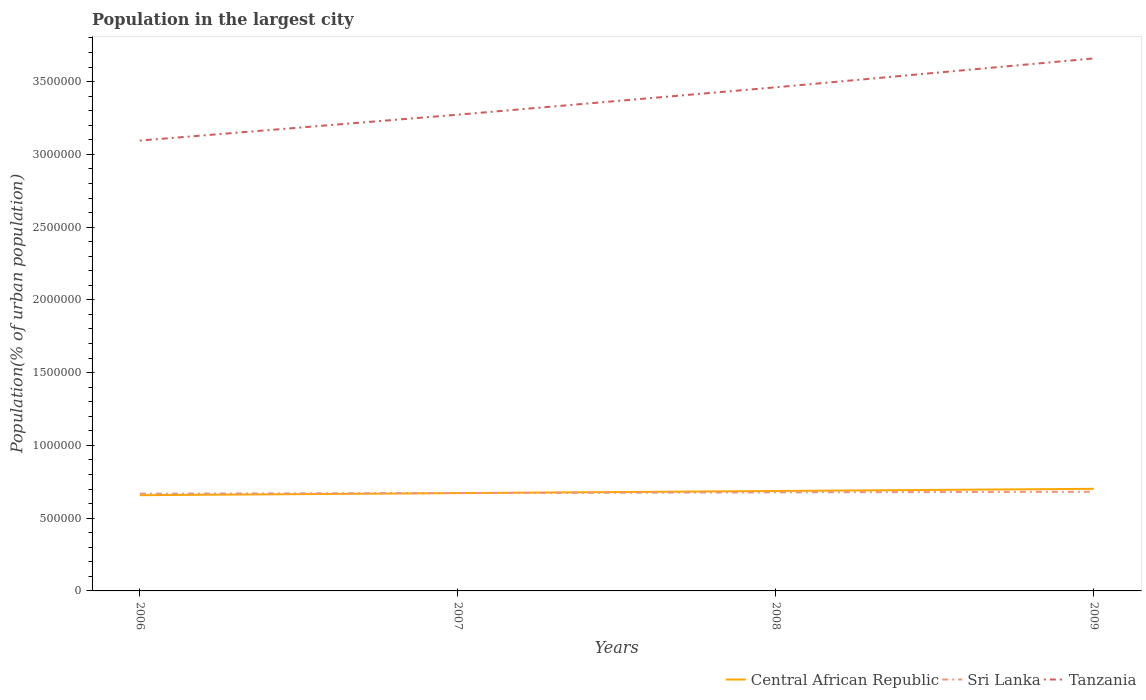Does the line corresponding to Sri Lanka intersect with the line corresponding to Central African Republic?
Your answer should be compact. Yes. Is the number of lines equal to the number of legend labels?
Keep it short and to the point. Yes. Across all years, what is the maximum population in the largest city in Central African Republic?
Ensure brevity in your answer.  6.58e+05. What is the total population in the largest city in Tanzania in the graph?
Keep it short and to the point. -1.78e+05. What is the difference between the highest and the second highest population in the largest city in Tanzania?
Ensure brevity in your answer.  5.65e+05. What is the difference between the highest and the lowest population in the largest city in Sri Lanka?
Make the answer very short. 2. How many years are there in the graph?
Give a very brief answer. 4. Does the graph contain any zero values?
Provide a succinct answer. No. How many legend labels are there?
Offer a terse response. 3. What is the title of the graph?
Your response must be concise. Population in the largest city. What is the label or title of the X-axis?
Your response must be concise. Years. What is the label or title of the Y-axis?
Your answer should be compact. Population(% of urban population). What is the Population(% of urban population) in Central African Republic in 2006?
Ensure brevity in your answer.  6.58e+05. What is the Population(% of urban population) in Sri Lanka in 2006?
Provide a short and direct response. 6.68e+05. What is the Population(% of urban population) in Tanzania in 2006?
Keep it short and to the point. 3.09e+06. What is the Population(% of urban population) of Central African Republic in 2007?
Offer a very short reply. 6.72e+05. What is the Population(% of urban population) of Sri Lanka in 2007?
Provide a succinct answer. 6.73e+05. What is the Population(% of urban population) of Tanzania in 2007?
Provide a short and direct response. 3.27e+06. What is the Population(% of urban population) of Central African Republic in 2008?
Keep it short and to the point. 6.87e+05. What is the Population(% of urban population) of Sri Lanka in 2008?
Your answer should be compact. 6.77e+05. What is the Population(% of urban population) in Tanzania in 2008?
Your answer should be very brief. 3.46e+06. What is the Population(% of urban population) in Central African Republic in 2009?
Give a very brief answer. 7.02e+05. What is the Population(% of urban population) in Sri Lanka in 2009?
Provide a short and direct response. 6.82e+05. What is the Population(% of urban population) in Tanzania in 2009?
Your response must be concise. 3.66e+06. Across all years, what is the maximum Population(% of urban population) of Central African Republic?
Provide a short and direct response. 7.02e+05. Across all years, what is the maximum Population(% of urban population) in Sri Lanka?
Ensure brevity in your answer.  6.82e+05. Across all years, what is the maximum Population(% of urban population) of Tanzania?
Offer a terse response. 3.66e+06. Across all years, what is the minimum Population(% of urban population) in Central African Republic?
Give a very brief answer. 6.58e+05. Across all years, what is the minimum Population(% of urban population) in Sri Lanka?
Your answer should be compact. 6.68e+05. Across all years, what is the minimum Population(% of urban population) of Tanzania?
Offer a terse response. 3.09e+06. What is the total Population(% of urban population) in Central African Republic in the graph?
Ensure brevity in your answer.  2.72e+06. What is the total Population(% of urban population) in Sri Lanka in the graph?
Your answer should be compact. 2.70e+06. What is the total Population(% of urban population) in Tanzania in the graph?
Make the answer very short. 1.35e+07. What is the difference between the Population(% of urban population) of Central African Republic in 2006 and that in 2007?
Your answer should be very brief. -1.42e+04. What is the difference between the Population(% of urban population) in Sri Lanka in 2006 and that in 2007?
Give a very brief answer. -4375. What is the difference between the Population(% of urban population) of Tanzania in 2006 and that in 2007?
Provide a succinct answer. -1.78e+05. What is the difference between the Population(% of urban population) in Central African Republic in 2006 and that in 2008?
Ensure brevity in your answer.  -2.88e+04. What is the difference between the Population(% of urban population) in Sri Lanka in 2006 and that in 2008?
Keep it short and to the point. -8785. What is the difference between the Population(% of urban population) in Tanzania in 2006 and that in 2008?
Give a very brief answer. -3.66e+05. What is the difference between the Population(% of urban population) in Central African Republic in 2006 and that in 2009?
Give a very brief answer. -4.36e+04. What is the difference between the Population(% of urban population) in Sri Lanka in 2006 and that in 2009?
Offer a very short reply. -1.32e+04. What is the difference between the Population(% of urban population) of Tanzania in 2006 and that in 2009?
Offer a very short reply. -5.65e+05. What is the difference between the Population(% of urban population) in Central African Republic in 2007 and that in 2008?
Your answer should be very brief. -1.45e+04. What is the difference between the Population(% of urban population) of Sri Lanka in 2007 and that in 2008?
Keep it short and to the point. -4410. What is the difference between the Population(% of urban population) of Tanzania in 2007 and that in 2008?
Provide a short and direct response. -1.88e+05. What is the difference between the Population(% of urban population) of Central African Republic in 2007 and that in 2009?
Your response must be concise. -2.94e+04. What is the difference between the Population(% of urban population) in Sri Lanka in 2007 and that in 2009?
Offer a terse response. -8849. What is the difference between the Population(% of urban population) in Tanzania in 2007 and that in 2009?
Provide a succinct answer. -3.87e+05. What is the difference between the Population(% of urban population) in Central African Republic in 2008 and that in 2009?
Provide a short and direct response. -1.49e+04. What is the difference between the Population(% of urban population) in Sri Lanka in 2008 and that in 2009?
Make the answer very short. -4439. What is the difference between the Population(% of urban population) in Tanzania in 2008 and that in 2009?
Keep it short and to the point. -1.99e+05. What is the difference between the Population(% of urban population) of Central African Republic in 2006 and the Population(% of urban population) of Sri Lanka in 2007?
Ensure brevity in your answer.  -1.48e+04. What is the difference between the Population(% of urban population) in Central African Republic in 2006 and the Population(% of urban population) in Tanzania in 2007?
Give a very brief answer. -2.61e+06. What is the difference between the Population(% of urban population) of Sri Lanka in 2006 and the Population(% of urban population) of Tanzania in 2007?
Provide a short and direct response. -2.60e+06. What is the difference between the Population(% of urban population) in Central African Republic in 2006 and the Population(% of urban population) in Sri Lanka in 2008?
Your answer should be very brief. -1.92e+04. What is the difference between the Population(% of urban population) in Central African Republic in 2006 and the Population(% of urban population) in Tanzania in 2008?
Provide a succinct answer. -2.80e+06. What is the difference between the Population(% of urban population) of Sri Lanka in 2006 and the Population(% of urban population) of Tanzania in 2008?
Provide a succinct answer. -2.79e+06. What is the difference between the Population(% of urban population) of Central African Republic in 2006 and the Population(% of urban population) of Sri Lanka in 2009?
Keep it short and to the point. -2.37e+04. What is the difference between the Population(% of urban population) of Central African Republic in 2006 and the Population(% of urban population) of Tanzania in 2009?
Offer a terse response. -3.00e+06. What is the difference between the Population(% of urban population) of Sri Lanka in 2006 and the Population(% of urban population) of Tanzania in 2009?
Provide a succinct answer. -2.99e+06. What is the difference between the Population(% of urban population) in Central African Republic in 2007 and the Population(% of urban population) in Sri Lanka in 2008?
Your response must be concise. -5004. What is the difference between the Population(% of urban population) of Central African Republic in 2007 and the Population(% of urban population) of Tanzania in 2008?
Offer a very short reply. -2.79e+06. What is the difference between the Population(% of urban population) in Sri Lanka in 2007 and the Population(% of urban population) in Tanzania in 2008?
Ensure brevity in your answer.  -2.79e+06. What is the difference between the Population(% of urban population) of Central African Republic in 2007 and the Population(% of urban population) of Sri Lanka in 2009?
Keep it short and to the point. -9443. What is the difference between the Population(% of urban population) in Central African Republic in 2007 and the Population(% of urban population) in Tanzania in 2009?
Offer a very short reply. -2.99e+06. What is the difference between the Population(% of urban population) of Sri Lanka in 2007 and the Population(% of urban population) of Tanzania in 2009?
Your response must be concise. -2.99e+06. What is the difference between the Population(% of urban population) in Central African Republic in 2008 and the Population(% of urban population) in Sri Lanka in 2009?
Keep it short and to the point. 5103. What is the difference between the Population(% of urban population) in Central African Republic in 2008 and the Population(% of urban population) in Tanzania in 2009?
Make the answer very short. -2.97e+06. What is the difference between the Population(% of urban population) in Sri Lanka in 2008 and the Population(% of urban population) in Tanzania in 2009?
Offer a terse response. -2.98e+06. What is the average Population(% of urban population) in Central African Republic per year?
Provide a short and direct response. 6.80e+05. What is the average Population(% of urban population) of Sri Lanka per year?
Your response must be concise. 6.75e+05. What is the average Population(% of urban population) in Tanzania per year?
Offer a very short reply. 3.37e+06. In the year 2006, what is the difference between the Population(% of urban population) in Central African Republic and Population(% of urban population) in Sri Lanka?
Ensure brevity in your answer.  -1.05e+04. In the year 2006, what is the difference between the Population(% of urban population) of Central African Republic and Population(% of urban population) of Tanzania?
Give a very brief answer. -2.44e+06. In the year 2006, what is the difference between the Population(% of urban population) of Sri Lanka and Population(% of urban population) of Tanzania?
Your answer should be compact. -2.43e+06. In the year 2007, what is the difference between the Population(% of urban population) of Central African Republic and Population(% of urban population) of Sri Lanka?
Provide a short and direct response. -594. In the year 2007, what is the difference between the Population(% of urban population) in Central African Republic and Population(% of urban population) in Tanzania?
Ensure brevity in your answer.  -2.60e+06. In the year 2007, what is the difference between the Population(% of urban population) in Sri Lanka and Population(% of urban population) in Tanzania?
Ensure brevity in your answer.  -2.60e+06. In the year 2008, what is the difference between the Population(% of urban population) in Central African Republic and Population(% of urban population) in Sri Lanka?
Offer a very short reply. 9542. In the year 2008, what is the difference between the Population(% of urban population) of Central African Republic and Population(% of urban population) of Tanzania?
Your answer should be very brief. -2.77e+06. In the year 2008, what is the difference between the Population(% of urban population) in Sri Lanka and Population(% of urban population) in Tanzania?
Provide a short and direct response. -2.78e+06. In the year 2009, what is the difference between the Population(% of urban population) in Central African Republic and Population(% of urban population) in Sri Lanka?
Provide a short and direct response. 2.00e+04. In the year 2009, what is the difference between the Population(% of urban population) of Central African Republic and Population(% of urban population) of Tanzania?
Give a very brief answer. -2.96e+06. In the year 2009, what is the difference between the Population(% of urban population) in Sri Lanka and Population(% of urban population) in Tanzania?
Your answer should be very brief. -2.98e+06. What is the ratio of the Population(% of urban population) in Central African Republic in 2006 to that in 2007?
Your response must be concise. 0.98. What is the ratio of the Population(% of urban population) of Sri Lanka in 2006 to that in 2007?
Give a very brief answer. 0.99. What is the ratio of the Population(% of urban population) in Tanzania in 2006 to that in 2007?
Provide a short and direct response. 0.95. What is the ratio of the Population(% of urban population) in Central African Republic in 2006 to that in 2008?
Your answer should be compact. 0.96. What is the ratio of the Population(% of urban population) in Tanzania in 2006 to that in 2008?
Your response must be concise. 0.89. What is the ratio of the Population(% of urban population) of Central African Republic in 2006 to that in 2009?
Provide a succinct answer. 0.94. What is the ratio of the Population(% of urban population) in Sri Lanka in 2006 to that in 2009?
Your answer should be very brief. 0.98. What is the ratio of the Population(% of urban population) of Tanzania in 2006 to that in 2009?
Your answer should be compact. 0.85. What is the ratio of the Population(% of urban population) of Central African Republic in 2007 to that in 2008?
Offer a very short reply. 0.98. What is the ratio of the Population(% of urban population) in Sri Lanka in 2007 to that in 2008?
Your answer should be compact. 0.99. What is the ratio of the Population(% of urban population) of Tanzania in 2007 to that in 2008?
Ensure brevity in your answer.  0.95. What is the ratio of the Population(% of urban population) of Central African Republic in 2007 to that in 2009?
Your response must be concise. 0.96. What is the ratio of the Population(% of urban population) in Tanzania in 2007 to that in 2009?
Give a very brief answer. 0.89. What is the ratio of the Population(% of urban population) in Central African Republic in 2008 to that in 2009?
Your answer should be very brief. 0.98. What is the ratio of the Population(% of urban population) of Sri Lanka in 2008 to that in 2009?
Provide a succinct answer. 0.99. What is the ratio of the Population(% of urban population) of Tanzania in 2008 to that in 2009?
Keep it short and to the point. 0.95. What is the difference between the highest and the second highest Population(% of urban population) in Central African Republic?
Provide a succinct answer. 1.49e+04. What is the difference between the highest and the second highest Population(% of urban population) in Sri Lanka?
Provide a short and direct response. 4439. What is the difference between the highest and the second highest Population(% of urban population) of Tanzania?
Provide a succinct answer. 1.99e+05. What is the difference between the highest and the lowest Population(% of urban population) in Central African Republic?
Provide a short and direct response. 4.36e+04. What is the difference between the highest and the lowest Population(% of urban population) in Sri Lanka?
Provide a succinct answer. 1.32e+04. What is the difference between the highest and the lowest Population(% of urban population) in Tanzania?
Make the answer very short. 5.65e+05. 